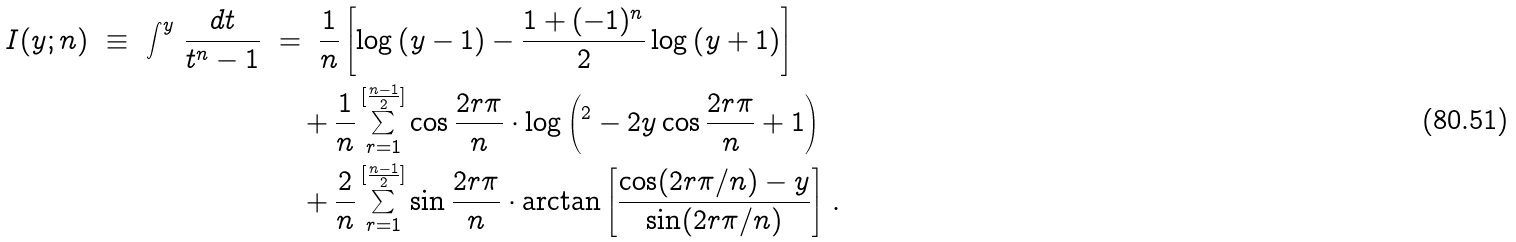Convert formula to latex. <formula><loc_0><loc_0><loc_500><loc_500>I ( y ; n ) \ \equiv \ \int ^ { y } \, \frac { d t } { t ^ { n } - 1 } \ & = \ \frac { 1 } { n } \left [ \log \left ( y - 1 \right ) - \frac { 1 + ( - 1 ) ^ { n } } { 2 } \log \left ( y + 1 \right ) \right ] \\ & \quad + \frac { 1 } { n } \sum _ { r = 1 } ^ { [ \frac { n - 1 } { 2 } ] } \cos \frac { 2 r \pi } { n } \cdot \log \left ( ^ { 2 } - 2 y \cos \frac { 2 r \pi } { n } + 1 \right ) \\ \ & \quad + \frac { 2 } { n } \sum _ { r = 1 } ^ { [ \frac { n - 1 } { 2 } ] } \sin \frac { 2 r \pi } { n } \cdot \arctan \left [ \frac { \cos ( 2 r \pi / n ) - y } { \sin ( 2 r \pi / n ) } \right ] \, .</formula> 